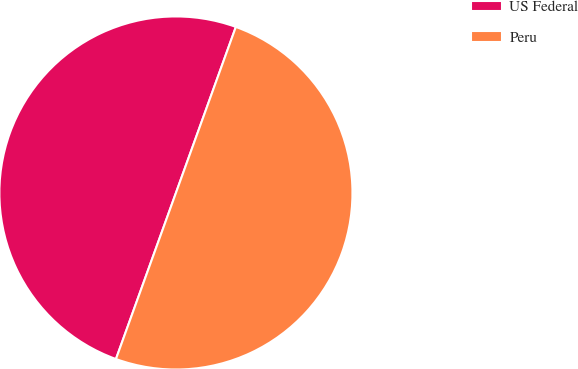<chart> <loc_0><loc_0><loc_500><loc_500><pie_chart><fcel>US Federal<fcel>Peru<nl><fcel>50.0%<fcel>50.0%<nl></chart> 